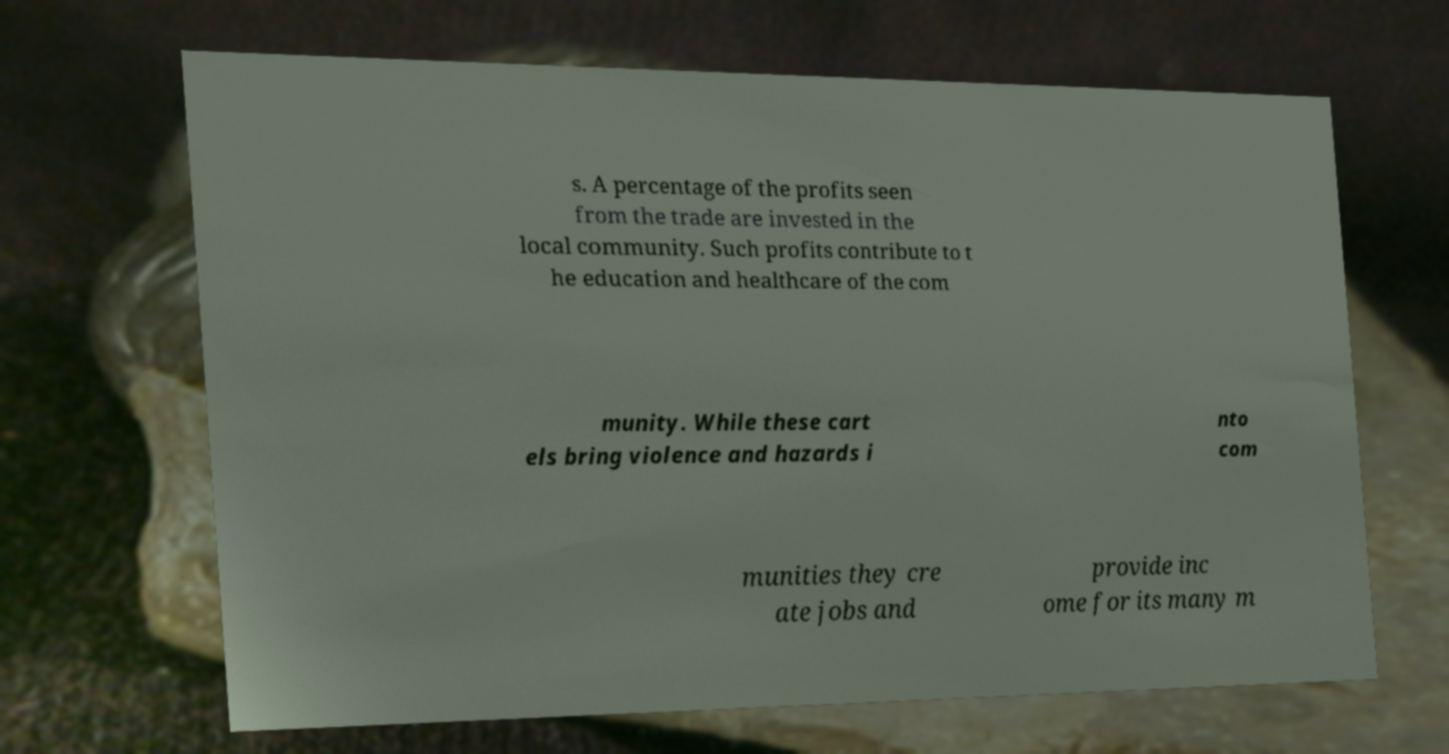Can you accurately transcribe the text from the provided image for me? s. A percentage of the profits seen from the trade are invested in the local community. Such profits contribute to t he education and healthcare of the com munity. While these cart els bring violence and hazards i nto com munities they cre ate jobs and provide inc ome for its many m 